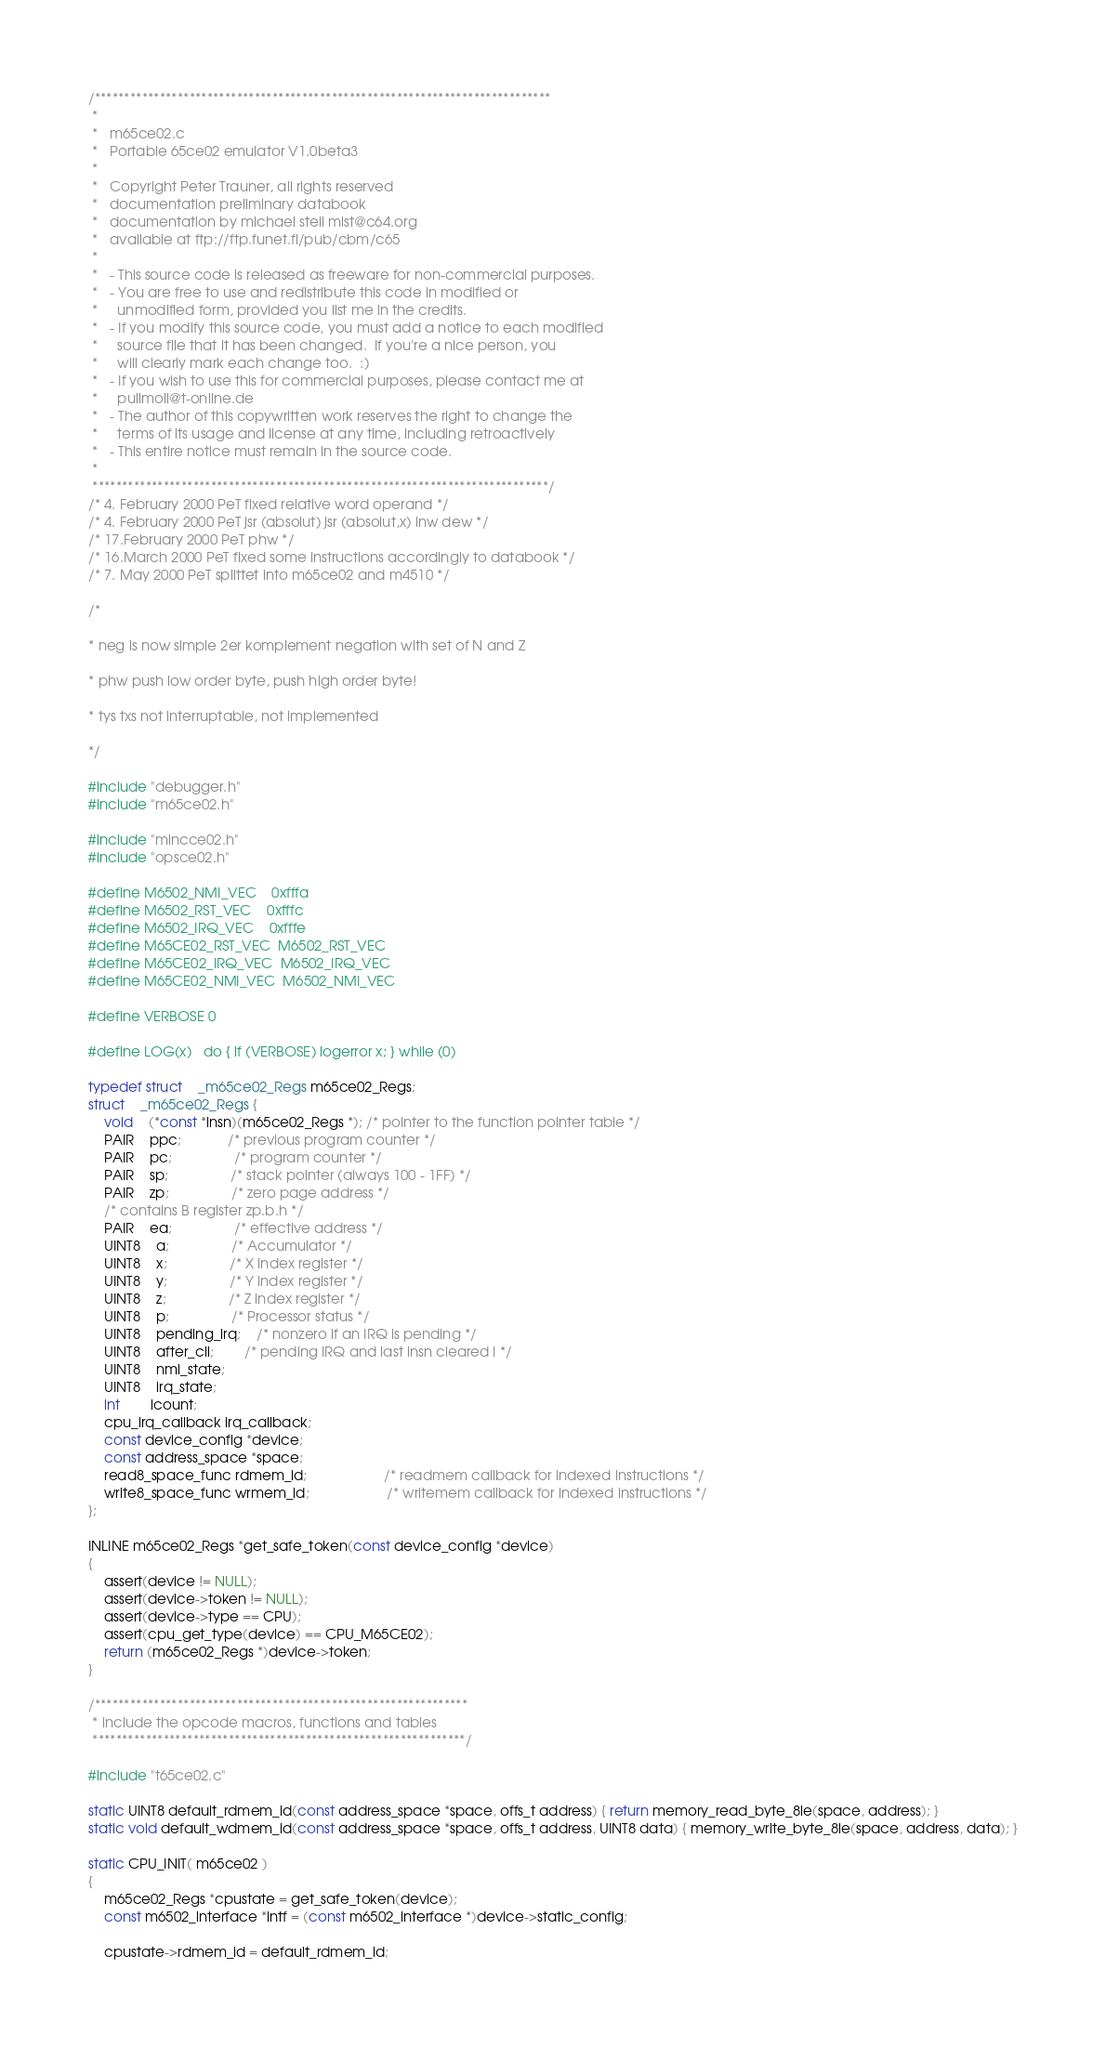<code> <loc_0><loc_0><loc_500><loc_500><_C_>/*****************************************************************************
 *
 *   m65ce02.c
 *   Portable 65ce02 emulator V1.0beta3
 *
 *   Copyright Peter Trauner, all rights reserved
 *   documentation preliminary databook
 *   documentation by michael steil mist@c64.org
 *   available at ftp://ftp.funet.fi/pub/cbm/c65
 *
 *   - This source code is released as freeware for non-commercial purposes.
 *   - You are free to use and redistribute this code in modified or
 *     unmodified form, provided you list me in the credits.
 *   - If you modify this source code, you must add a notice to each modified
 *     source file that it has been changed.  If you're a nice person, you
 *     will clearly mark each change too.  :)
 *   - If you wish to use this for commercial purposes, please contact me at
 *     pullmoll@t-online.de
 *   - The author of this copywritten work reserves the right to change the
 *     terms of its usage and license at any time, including retroactively
 *   - This entire notice must remain in the source code.
 *
 *****************************************************************************/
/* 4. February 2000 PeT fixed relative word operand */
/* 4. February 2000 PeT jsr (absolut) jsr (absolut,x) inw dew */
/* 17.February 2000 PeT phw */
/* 16.March 2000 PeT fixed some instructions accordingly to databook */
/* 7. May 2000 PeT splittet into m65ce02 and m4510 */

/*

* neg is now simple 2er komplement negation with set of N and Z

* phw push low order byte, push high order byte!

* tys txs not interruptable, not implemented

*/

#include "debugger.h"
#include "m65ce02.h"

#include "mincce02.h"
#include "opsce02.h"

#define M6502_NMI_VEC	0xfffa
#define M6502_RST_VEC	0xfffc
#define M6502_IRQ_VEC	0xfffe
#define M65CE02_RST_VEC	M6502_RST_VEC
#define M65CE02_IRQ_VEC	M6502_IRQ_VEC
#define M65CE02_NMI_VEC	M6502_NMI_VEC

#define VERBOSE 0

#define LOG(x)	do { if (VERBOSE) logerror x; } while (0)

typedef struct 	_m65ce02_Regs m65ce02_Regs;
struct 	_m65ce02_Regs {
	void	(*const *insn)(m65ce02_Regs *); /* pointer to the function pointer table */
	PAIR	ppc;			/* previous program counter */
	PAIR	pc;				/* program counter */
	PAIR	sp;				/* stack pointer (always 100 - 1FF) */
	PAIR	zp;				/* zero page address */
	/* contains B register zp.b.h */
	PAIR	ea;				/* effective address */
	UINT8	a;				/* Accumulator */
	UINT8	x;				/* X index register */
	UINT8	y;				/* Y index register */
	UINT8	z;				/* Z index register */
	UINT8	p;				/* Processor status */
	UINT8	pending_irq;	/* nonzero if an IRQ is pending */
	UINT8	after_cli;		/* pending IRQ and last insn cleared I */
	UINT8	nmi_state;
	UINT8	irq_state;
	int		icount;
	cpu_irq_callback irq_callback;
	const device_config *device;
	const address_space *space;
	read8_space_func rdmem_id;					/* readmem callback for indexed instructions */
	write8_space_func wrmem_id;					/* writemem callback for indexed instructions */
};

INLINE m65ce02_Regs *get_safe_token(const device_config *device)
{
	assert(device != NULL);
	assert(device->token != NULL);
	assert(device->type == CPU);
	assert(cpu_get_type(device) == CPU_M65CE02);
	return (m65ce02_Regs *)device->token;
}

/***************************************************************
 * include the opcode macros, functions and tables
 ***************************************************************/

#include "t65ce02.c"

static UINT8 default_rdmem_id(const address_space *space, offs_t address) { return memory_read_byte_8le(space, address); }
static void default_wdmem_id(const address_space *space, offs_t address, UINT8 data) { memory_write_byte_8le(space, address, data); }

static CPU_INIT( m65ce02 )
{
	m65ce02_Regs *cpustate = get_safe_token(device);
	const m6502_interface *intf = (const m6502_interface *)device->static_config;

	cpustate->rdmem_id = default_rdmem_id;</code> 